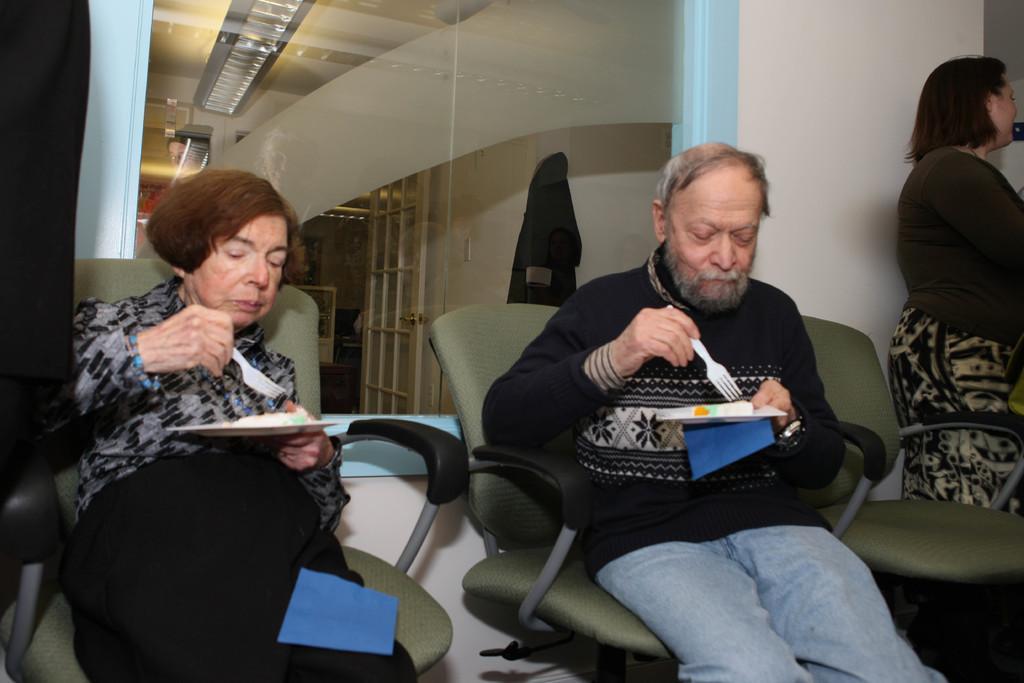How would you summarize this image in a sentence or two? In this image we can see there are two persons sitting on the chairs and holding plates and spoon with some food items. And we can see the other person standing. In the background, we can see a glass, through the glass we can see a cloth, door, box and ceiling with lights. 